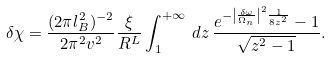<formula> <loc_0><loc_0><loc_500><loc_500>\delta \chi = \frac { ( 2 \pi l _ { B } ^ { 2 } ) ^ { - 2 } } { 2 \pi ^ { 2 } v ^ { 2 } } \frac { \xi } { R ^ { L } } \int _ { 1 } ^ { + \infty } \, d z \, \frac { e ^ { - \left | \frac { \delta \omega } { \Omega _ { n } } \right | ^ { 2 } \frac { 1 } { 8 z ^ { 2 } } } - 1 } { \sqrt { z ^ { 2 } - 1 } } .</formula> 